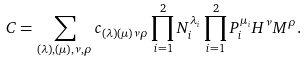<formula> <loc_0><loc_0><loc_500><loc_500>C = \sum _ { ( \lambda ) , ( \mu ) , \nu , \rho } c _ { ( \lambda ) ( \mu ) \nu \rho } \prod _ { i = 1 } ^ { 2 } N _ { i } ^ { \lambda _ { i } } \prod _ { i = 1 } ^ { 2 } P _ { i } ^ { \mu _ { i } } H ^ { \nu } M ^ { \rho } .</formula> 